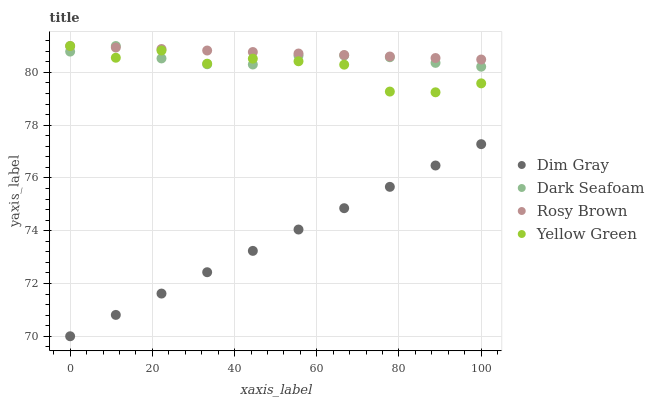Does Dim Gray have the minimum area under the curve?
Answer yes or no. Yes. Does Rosy Brown have the maximum area under the curve?
Answer yes or no. Yes. Does Yellow Green have the minimum area under the curve?
Answer yes or no. No. Does Yellow Green have the maximum area under the curve?
Answer yes or no. No. Is Rosy Brown the smoothest?
Answer yes or no. Yes. Is Yellow Green the roughest?
Answer yes or no. Yes. Is Dim Gray the smoothest?
Answer yes or no. No. Is Dim Gray the roughest?
Answer yes or no. No. Does Dim Gray have the lowest value?
Answer yes or no. Yes. Does Yellow Green have the lowest value?
Answer yes or no. No. Does Rosy Brown have the highest value?
Answer yes or no. Yes. Does Dim Gray have the highest value?
Answer yes or no. No. Is Dim Gray less than Rosy Brown?
Answer yes or no. Yes. Is Rosy Brown greater than Dim Gray?
Answer yes or no. Yes. Does Yellow Green intersect Rosy Brown?
Answer yes or no. Yes. Is Yellow Green less than Rosy Brown?
Answer yes or no. No. Is Yellow Green greater than Rosy Brown?
Answer yes or no. No. Does Dim Gray intersect Rosy Brown?
Answer yes or no. No. 